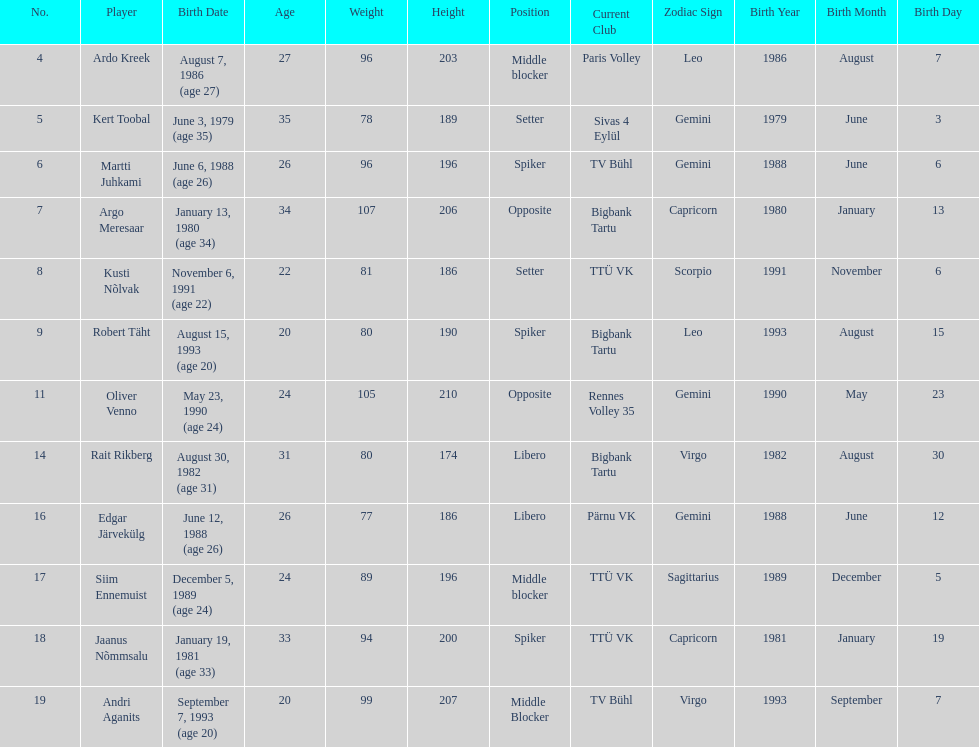What is the height difference between oliver venno and rait rikberg? 36. 